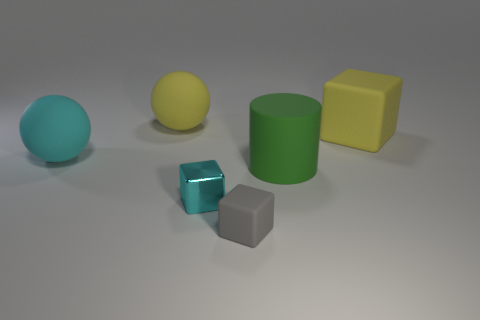There is another gray thing that is the same shape as the metallic thing; what size is it?
Your answer should be very brief. Small. How many other objects are the same size as the gray thing?
Provide a succinct answer. 1. Do the yellow cube and the green cylinder have the same size?
Ensure brevity in your answer.  Yes. Are there any big cubes?
Offer a very short reply. Yes. Is there anything else that has the same material as the tiny cyan object?
Offer a very short reply. No. Is there a big green thing that has the same material as the big cyan object?
Provide a succinct answer. Yes. There is a cyan thing that is the same size as the gray object; what is it made of?
Your answer should be very brief. Metal. How many yellow things have the same shape as the gray rubber object?
Keep it short and to the point. 1. There is a yellow cube that is made of the same material as the gray object; what size is it?
Offer a very short reply. Large. There is a cube that is behind the gray cube and to the left of the large green cylinder; what is its material?
Give a very brief answer. Metal. 